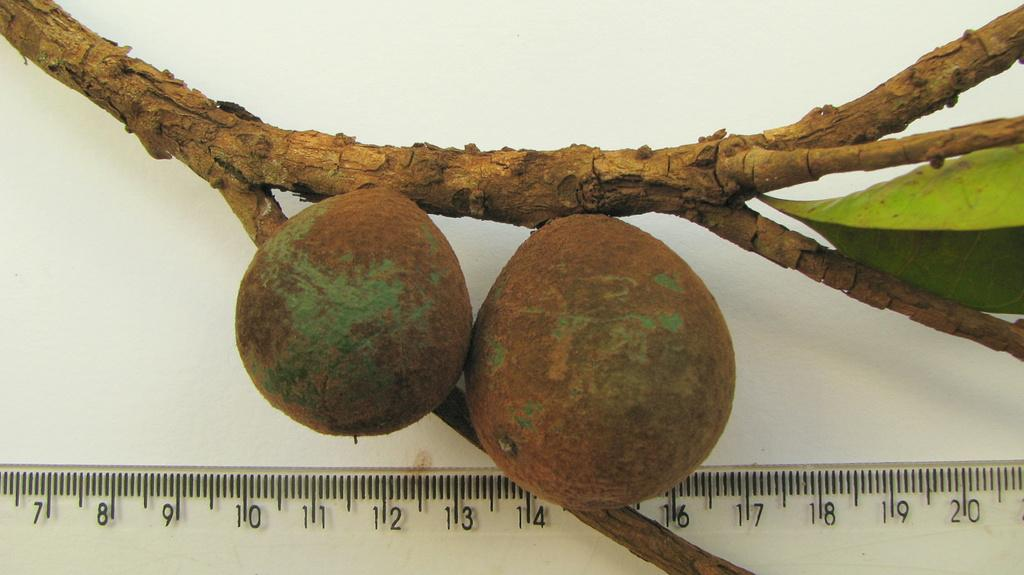<image>
Summarize the visual content of the image. A section of a ruler is displayed and it shows the numbers from 7 to 20 on it. 